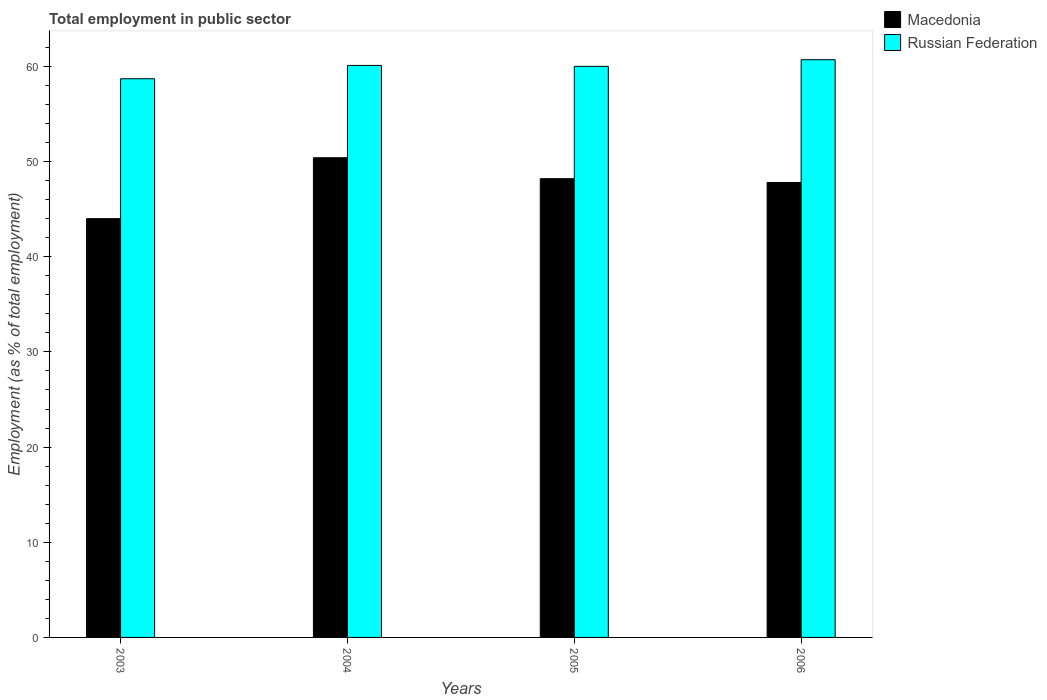How many different coloured bars are there?
Offer a terse response. 2. How many bars are there on the 1st tick from the left?
Your answer should be compact. 2. How many bars are there on the 3rd tick from the right?
Provide a short and direct response. 2. What is the employment in public sector in Russian Federation in 2006?
Provide a succinct answer. 60.7. Across all years, what is the maximum employment in public sector in Macedonia?
Your answer should be compact. 50.4. Across all years, what is the minimum employment in public sector in Russian Federation?
Keep it short and to the point. 58.7. In which year was the employment in public sector in Macedonia maximum?
Ensure brevity in your answer.  2004. What is the total employment in public sector in Macedonia in the graph?
Make the answer very short. 190.4. What is the difference between the employment in public sector in Russian Federation in 2003 and that in 2006?
Your answer should be very brief. -2. What is the difference between the employment in public sector in Russian Federation in 2003 and the employment in public sector in Macedonia in 2006?
Ensure brevity in your answer.  10.9. What is the average employment in public sector in Russian Federation per year?
Offer a terse response. 59.88. In the year 2003, what is the difference between the employment in public sector in Macedonia and employment in public sector in Russian Federation?
Provide a succinct answer. -14.7. In how many years, is the employment in public sector in Macedonia greater than 32 %?
Offer a very short reply. 4. What is the ratio of the employment in public sector in Russian Federation in 2003 to that in 2005?
Give a very brief answer. 0.98. Is the difference between the employment in public sector in Macedonia in 2004 and 2006 greater than the difference between the employment in public sector in Russian Federation in 2004 and 2006?
Keep it short and to the point. Yes. What is the difference between the highest and the second highest employment in public sector in Russian Federation?
Offer a terse response. 0.6. What is the difference between the highest and the lowest employment in public sector in Macedonia?
Provide a short and direct response. 6.4. In how many years, is the employment in public sector in Russian Federation greater than the average employment in public sector in Russian Federation taken over all years?
Your answer should be very brief. 3. What does the 1st bar from the left in 2006 represents?
Keep it short and to the point. Macedonia. What does the 1st bar from the right in 2005 represents?
Your response must be concise. Russian Federation. How many years are there in the graph?
Offer a very short reply. 4. What is the difference between two consecutive major ticks on the Y-axis?
Provide a succinct answer. 10. Does the graph contain any zero values?
Provide a short and direct response. No. Does the graph contain grids?
Make the answer very short. No. Where does the legend appear in the graph?
Keep it short and to the point. Top right. How many legend labels are there?
Your answer should be compact. 2. How are the legend labels stacked?
Offer a very short reply. Vertical. What is the title of the graph?
Ensure brevity in your answer.  Total employment in public sector. Does "Congo (Democratic)" appear as one of the legend labels in the graph?
Offer a very short reply. No. What is the label or title of the X-axis?
Your answer should be very brief. Years. What is the label or title of the Y-axis?
Provide a short and direct response. Employment (as % of total employment). What is the Employment (as % of total employment) of Macedonia in 2003?
Give a very brief answer. 44. What is the Employment (as % of total employment) in Russian Federation in 2003?
Ensure brevity in your answer.  58.7. What is the Employment (as % of total employment) of Macedonia in 2004?
Offer a very short reply. 50.4. What is the Employment (as % of total employment) in Russian Federation in 2004?
Provide a succinct answer. 60.1. What is the Employment (as % of total employment) in Macedonia in 2005?
Provide a succinct answer. 48.2. What is the Employment (as % of total employment) in Russian Federation in 2005?
Make the answer very short. 60. What is the Employment (as % of total employment) in Macedonia in 2006?
Make the answer very short. 47.8. What is the Employment (as % of total employment) of Russian Federation in 2006?
Provide a short and direct response. 60.7. Across all years, what is the maximum Employment (as % of total employment) in Macedonia?
Ensure brevity in your answer.  50.4. Across all years, what is the maximum Employment (as % of total employment) in Russian Federation?
Your answer should be very brief. 60.7. Across all years, what is the minimum Employment (as % of total employment) in Russian Federation?
Provide a succinct answer. 58.7. What is the total Employment (as % of total employment) of Macedonia in the graph?
Keep it short and to the point. 190.4. What is the total Employment (as % of total employment) of Russian Federation in the graph?
Provide a succinct answer. 239.5. What is the difference between the Employment (as % of total employment) in Russian Federation in 2003 and that in 2004?
Give a very brief answer. -1.4. What is the difference between the Employment (as % of total employment) of Russian Federation in 2003 and that in 2005?
Provide a short and direct response. -1.3. What is the difference between the Employment (as % of total employment) in Macedonia in 2004 and that in 2005?
Keep it short and to the point. 2.2. What is the difference between the Employment (as % of total employment) in Russian Federation in 2004 and that in 2005?
Your answer should be very brief. 0.1. What is the difference between the Employment (as % of total employment) of Macedonia in 2004 and that in 2006?
Provide a succinct answer. 2.6. What is the difference between the Employment (as % of total employment) of Macedonia in 2005 and that in 2006?
Ensure brevity in your answer.  0.4. What is the difference between the Employment (as % of total employment) of Russian Federation in 2005 and that in 2006?
Provide a succinct answer. -0.7. What is the difference between the Employment (as % of total employment) of Macedonia in 2003 and the Employment (as % of total employment) of Russian Federation in 2004?
Your answer should be compact. -16.1. What is the difference between the Employment (as % of total employment) in Macedonia in 2003 and the Employment (as % of total employment) in Russian Federation in 2005?
Your answer should be compact. -16. What is the difference between the Employment (as % of total employment) of Macedonia in 2003 and the Employment (as % of total employment) of Russian Federation in 2006?
Keep it short and to the point. -16.7. What is the difference between the Employment (as % of total employment) of Macedonia in 2004 and the Employment (as % of total employment) of Russian Federation in 2005?
Provide a succinct answer. -9.6. What is the difference between the Employment (as % of total employment) in Macedonia in 2005 and the Employment (as % of total employment) in Russian Federation in 2006?
Offer a very short reply. -12.5. What is the average Employment (as % of total employment) of Macedonia per year?
Your answer should be very brief. 47.6. What is the average Employment (as % of total employment) of Russian Federation per year?
Your response must be concise. 59.88. In the year 2003, what is the difference between the Employment (as % of total employment) of Macedonia and Employment (as % of total employment) of Russian Federation?
Give a very brief answer. -14.7. In the year 2004, what is the difference between the Employment (as % of total employment) of Macedonia and Employment (as % of total employment) of Russian Federation?
Provide a succinct answer. -9.7. In the year 2005, what is the difference between the Employment (as % of total employment) of Macedonia and Employment (as % of total employment) of Russian Federation?
Ensure brevity in your answer.  -11.8. What is the ratio of the Employment (as % of total employment) of Macedonia in 2003 to that in 2004?
Your answer should be compact. 0.87. What is the ratio of the Employment (as % of total employment) of Russian Federation in 2003 to that in 2004?
Offer a very short reply. 0.98. What is the ratio of the Employment (as % of total employment) in Macedonia in 2003 to that in 2005?
Give a very brief answer. 0.91. What is the ratio of the Employment (as % of total employment) in Russian Federation in 2003 to that in 2005?
Offer a terse response. 0.98. What is the ratio of the Employment (as % of total employment) of Macedonia in 2003 to that in 2006?
Give a very brief answer. 0.92. What is the ratio of the Employment (as % of total employment) of Russian Federation in 2003 to that in 2006?
Your answer should be compact. 0.97. What is the ratio of the Employment (as % of total employment) in Macedonia in 2004 to that in 2005?
Provide a short and direct response. 1.05. What is the ratio of the Employment (as % of total employment) in Russian Federation in 2004 to that in 2005?
Your answer should be compact. 1. What is the ratio of the Employment (as % of total employment) of Macedonia in 2004 to that in 2006?
Your answer should be compact. 1.05. What is the ratio of the Employment (as % of total employment) of Russian Federation in 2004 to that in 2006?
Your answer should be compact. 0.99. What is the ratio of the Employment (as % of total employment) of Macedonia in 2005 to that in 2006?
Offer a very short reply. 1.01. What is the difference between the highest and the lowest Employment (as % of total employment) in Macedonia?
Your answer should be compact. 6.4. What is the difference between the highest and the lowest Employment (as % of total employment) in Russian Federation?
Your answer should be compact. 2. 